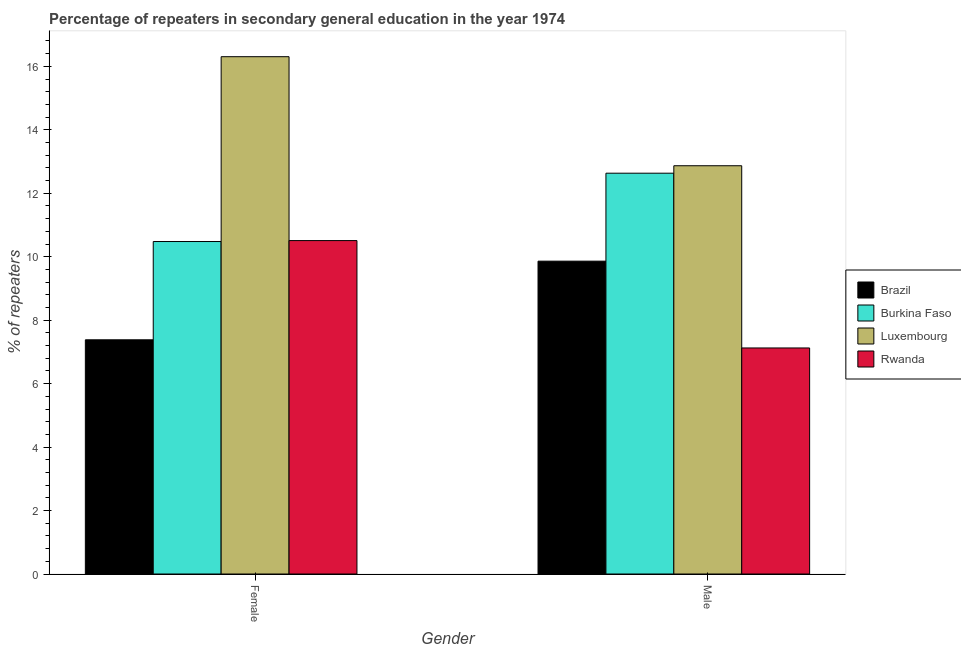How many groups of bars are there?
Provide a short and direct response. 2. Are the number of bars per tick equal to the number of legend labels?
Ensure brevity in your answer.  Yes. Are the number of bars on each tick of the X-axis equal?
Your answer should be compact. Yes. How many bars are there on the 1st tick from the left?
Your answer should be very brief. 4. How many bars are there on the 1st tick from the right?
Keep it short and to the point. 4. What is the label of the 2nd group of bars from the left?
Provide a succinct answer. Male. What is the percentage of female repeaters in Rwanda?
Your response must be concise. 10.51. Across all countries, what is the maximum percentage of male repeaters?
Make the answer very short. 12.87. Across all countries, what is the minimum percentage of female repeaters?
Offer a terse response. 7.38. In which country was the percentage of male repeaters maximum?
Your response must be concise. Luxembourg. In which country was the percentage of male repeaters minimum?
Your response must be concise. Rwanda. What is the total percentage of female repeaters in the graph?
Make the answer very short. 44.67. What is the difference between the percentage of male repeaters in Rwanda and that in Luxembourg?
Provide a short and direct response. -5.74. What is the difference between the percentage of male repeaters in Rwanda and the percentage of female repeaters in Luxembourg?
Offer a very short reply. -9.18. What is the average percentage of male repeaters per country?
Your answer should be very brief. 10.62. What is the difference between the percentage of male repeaters and percentage of female repeaters in Rwanda?
Offer a terse response. -3.38. What is the ratio of the percentage of female repeaters in Brazil to that in Luxembourg?
Offer a very short reply. 0.45. Is the percentage of female repeaters in Luxembourg less than that in Rwanda?
Keep it short and to the point. No. In how many countries, is the percentage of male repeaters greater than the average percentage of male repeaters taken over all countries?
Offer a very short reply. 2. What does the 3rd bar from the right in Male represents?
Offer a terse response. Burkina Faso. How many bars are there?
Provide a short and direct response. 8. Are all the bars in the graph horizontal?
Provide a succinct answer. No. How many countries are there in the graph?
Make the answer very short. 4. Where does the legend appear in the graph?
Give a very brief answer. Center right. How many legend labels are there?
Offer a terse response. 4. How are the legend labels stacked?
Ensure brevity in your answer.  Vertical. What is the title of the graph?
Offer a terse response. Percentage of repeaters in secondary general education in the year 1974. Does "Burundi" appear as one of the legend labels in the graph?
Your response must be concise. No. What is the label or title of the X-axis?
Provide a succinct answer. Gender. What is the label or title of the Y-axis?
Your answer should be very brief. % of repeaters. What is the % of repeaters in Brazil in Female?
Offer a terse response. 7.38. What is the % of repeaters of Burkina Faso in Female?
Your answer should be very brief. 10.48. What is the % of repeaters in Luxembourg in Female?
Make the answer very short. 16.3. What is the % of repeaters of Rwanda in Female?
Your answer should be very brief. 10.51. What is the % of repeaters in Brazil in Male?
Provide a short and direct response. 9.86. What is the % of repeaters in Burkina Faso in Male?
Provide a succinct answer. 12.63. What is the % of repeaters in Luxembourg in Male?
Provide a succinct answer. 12.87. What is the % of repeaters of Rwanda in Male?
Keep it short and to the point. 7.12. Across all Gender, what is the maximum % of repeaters of Brazil?
Give a very brief answer. 9.86. Across all Gender, what is the maximum % of repeaters in Burkina Faso?
Make the answer very short. 12.63. Across all Gender, what is the maximum % of repeaters in Luxembourg?
Keep it short and to the point. 16.3. Across all Gender, what is the maximum % of repeaters of Rwanda?
Provide a succinct answer. 10.51. Across all Gender, what is the minimum % of repeaters of Brazil?
Keep it short and to the point. 7.38. Across all Gender, what is the minimum % of repeaters in Burkina Faso?
Provide a short and direct response. 10.48. Across all Gender, what is the minimum % of repeaters of Luxembourg?
Your answer should be compact. 12.87. Across all Gender, what is the minimum % of repeaters of Rwanda?
Your answer should be compact. 7.12. What is the total % of repeaters of Brazil in the graph?
Your response must be concise. 17.24. What is the total % of repeaters in Burkina Faso in the graph?
Give a very brief answer. 23.11. What is the total % of repeaters in Luxembourg in the graph?
Provide a short and direct response. 29.17. What is the total % of repeaters of Rwanda in the graph?
Provide a short and direct response. 17.63. What is the difference between the % of repeaters of Brazil in Female and that in Male?
Offer a very short reply. -2.48. What is the difference between the % of repeaters in Burkina Faso in Female and that in Male?
Provide a short and direct response. -2.15. What is the difference between the % of repeaters in Luxembourg in Female and that in Male?
Give a very brief answer. 3.44. What is the difference between the % of repeaters of Rwanda in Female and that in Male?
Make the answer very short. 3.38. What is the difference between the % of repeaters of Brazil in Female and the % of repeaters of Burkina Faso in Male?
Ensure brevity in your answer.  -5.25. What is the difference between the % of repeaters of Brazil in Female and the % of repeaters of Luxembourg in Male?
Offer a terse response. -5.49. What is the difference between the % of repeaters in Brazil in Female and the % of repeaters in Rwanda in Male?
Give a very brief answer. 0.26. What is the difference between the % of repeaters of Burkina Faso in Female and the % of repeaters of Luxembourg in Male?
Your answer should be compact. -2.39. What is the difference between the % of repeaters of Burkina Faso in Female and the % of repeaters of Rwanda in Male?
Make the answer very short. 3.35. What is the difference between the % of repeaters in Luxembourg in Female and the % of repeaters in Rwanda in Male?
Offer a very short reply. 9.18. What is the average % of repeaters in Brazil per Gender?
Provide a short and direct response. 8.62. What is the average % of repeaters of Burkina Faso per Gender?
Provide a short and direct response. 11.56. What is the average % of repeaters of Luxembourg per Gender?
Provide a short and direct response. 14.59. What is the average % of repeaters of Rwanda per Gender?
Offer a very short reply. 8.82. What is the difference between the % of repeaters in Brazil and % of repeaters in Burkina Faso in Female?
Provide a succinct answer. -3.1. What is the difference between the % of repeaters in Brazil and % of repeaters in Luxembourg in Female?
Keep it short and to the point. -8.92. What is the difference between the % of repeaters of Brazil and % of repeaters of Rwanda in Female?
Offer a terse response. -3.13. What is the difference between the % of repeaters of Burkina Faso and % of repeaters of Luxembourg in Female?
Offer a very short reply. -5.83. What is the difference between the % of repeaters of Burkina Faso and % of repeaters of Rwanda in Female?
Make the answer very short. -0.03. What is the difference between the % of repeaters in Luxembourg and % of repeaters in Rwanda in Female?
Keep it short and to the point. 5.8. What is the difference between the % of repeaters in Brazil and % of repeaters in Burkina Faso in Male?
Ensure brevity in your answer.  -2.77. What is the difference between the % of repeaters in Brazil and % of repeaters in Luxembourg in Male?
Provide a short and direct response. -3.01. What is the difference between the % of repeaters of Brazil and % of repeaters of Rwanda in Male?
Keep it short and to the point. 2.74. What is the difference between the % of repeaters in Burkina Faso and % of repeaters in Luxembourg in Male?
Your response must be concise. -0.23. What is the difference between the % of repeaters in Burkina Faso and % of repeaters in Rwanda in Male?
Give a very brief answer. 5.51. What is the difference between the % of repeaters of Luxembourg and % of repeaters of Rwanda in Male?
Provide a short and direct response. 5.74. What is the ratio of the % of repeaters of Brazil in Female to that in Male?
Offer a terse response. 0.75. What is the ratio of the % of repeaters of Burkina Faso in Female to that in Male?
Offer a terse response. 0.83. What is the ratio of the % of repeaters in Luxembourg in Female to that in Male?
Make the answer very short. 1.27. What is the ratio of the % of repeaters in Rwanda in Female to that in Male?
Your response must be concise. 1.48. What is the difference between the highest and the second highest % of repeaters in Brazil?
Give a very brief answer. 2.48. What is the difference between the highest and the second highest % of repeaters of Burkina Faso?
Your response must be concise. 2.15. What is the difference between the highest and the second highest % of repeaters of Luxembourg?
Provide a short and direct response. 3.44. What is the difference between the highest and the second highest % of repeaters of Rwanda?
Your answer should be very brief. 3.38. What is the difference between the highest and the lowest % of repeaters of Brazil?
Your answer should be compact. 2.48. What is the difference between the highest and the lowest % of repeaters in Burkina Faso?
Provide a succinct answer. 2.15. What is the difference between the highest and the lowest % of repeaters in Luxembourg?
Your answer should be compact. 3.44. What is the difference between the highest and the lowest % of repeaters in Rwanda?
Offer a very short reply. 3.38. 